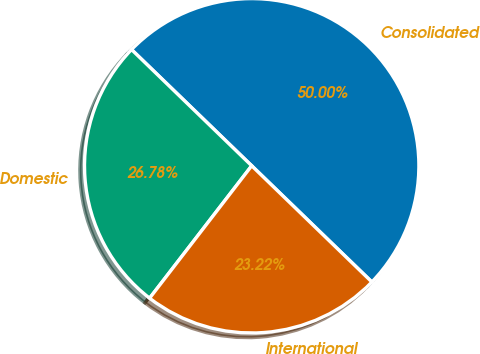<chart> <loc_0><loc_0><loc_500><loc_500><pie_chart><fcel>Consolidated<fcel>Domestic<fcel>International<nl><fcel>50.0%<fcel>26.78%<fcel>23.22%<nl></chart> 